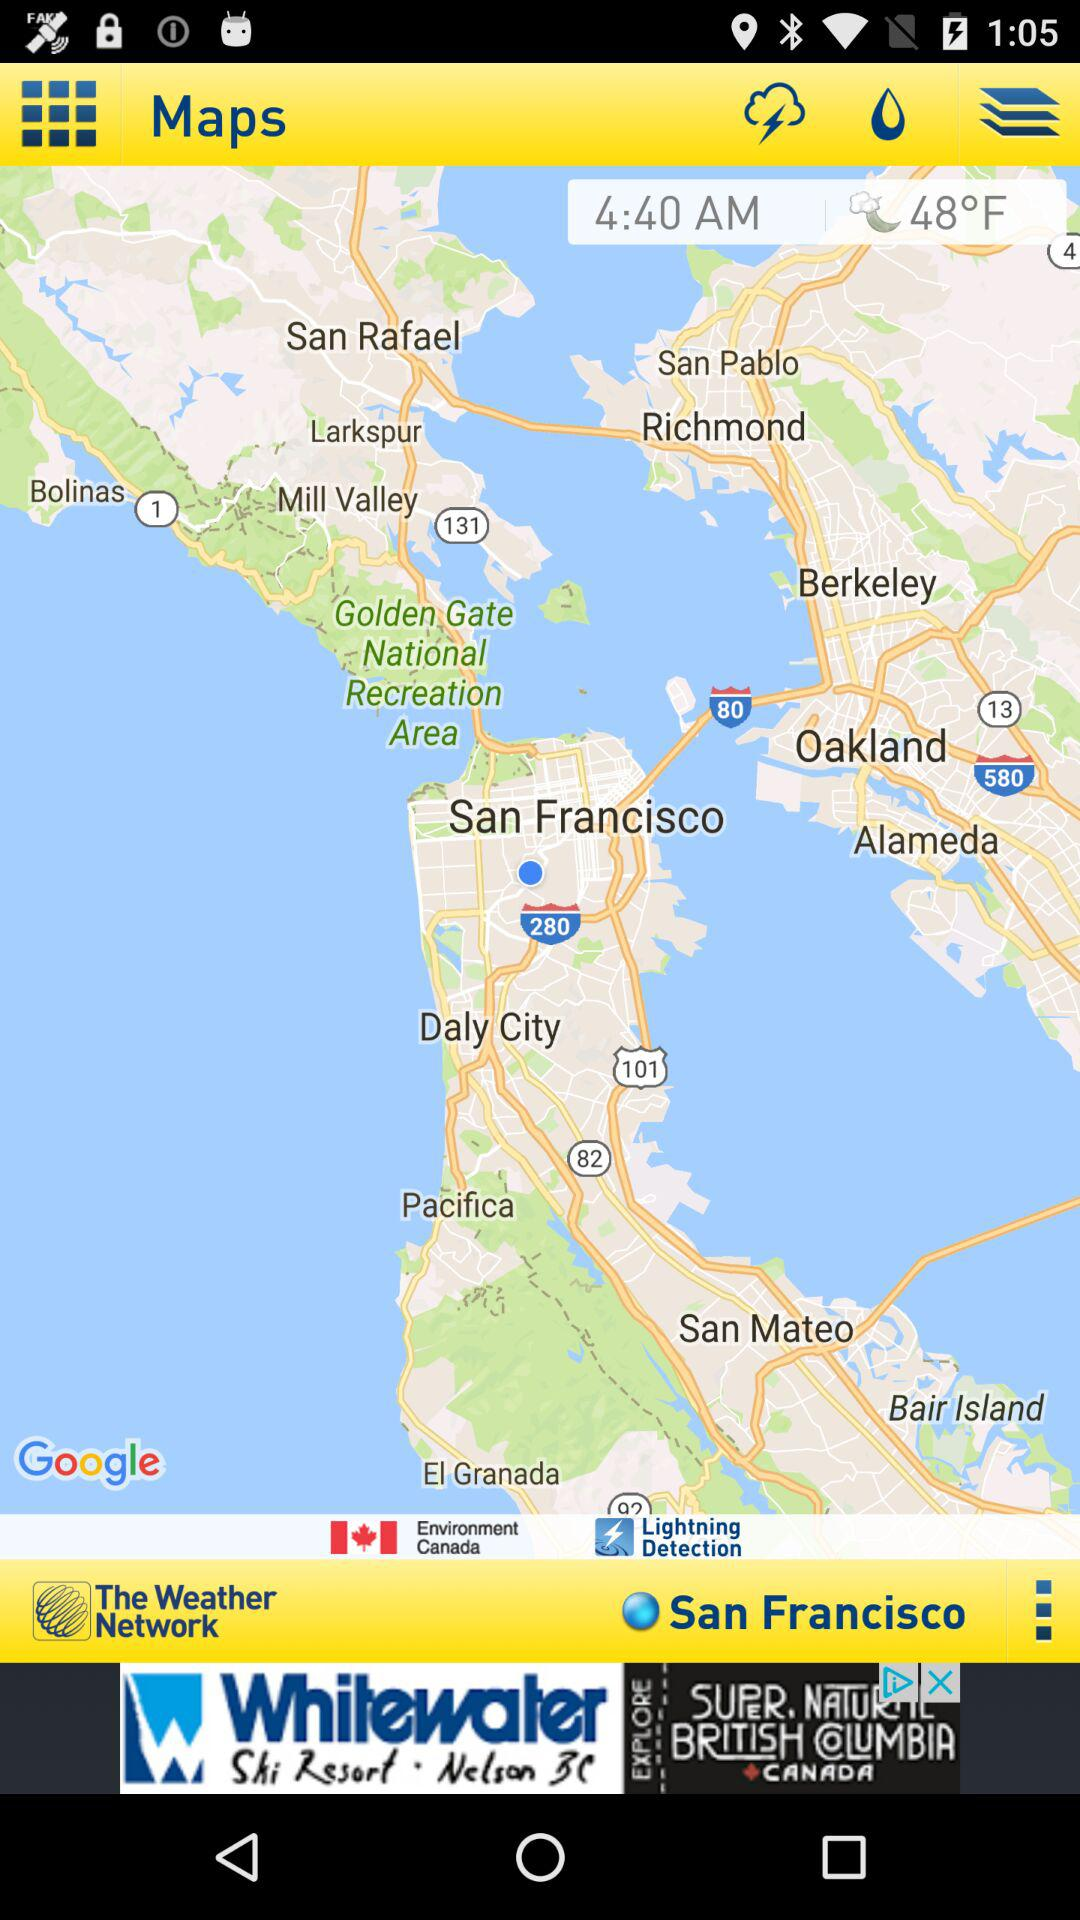How many degrees Fahrenheit is the temperature?
Answer the question using a single word or phrase. 48°F 